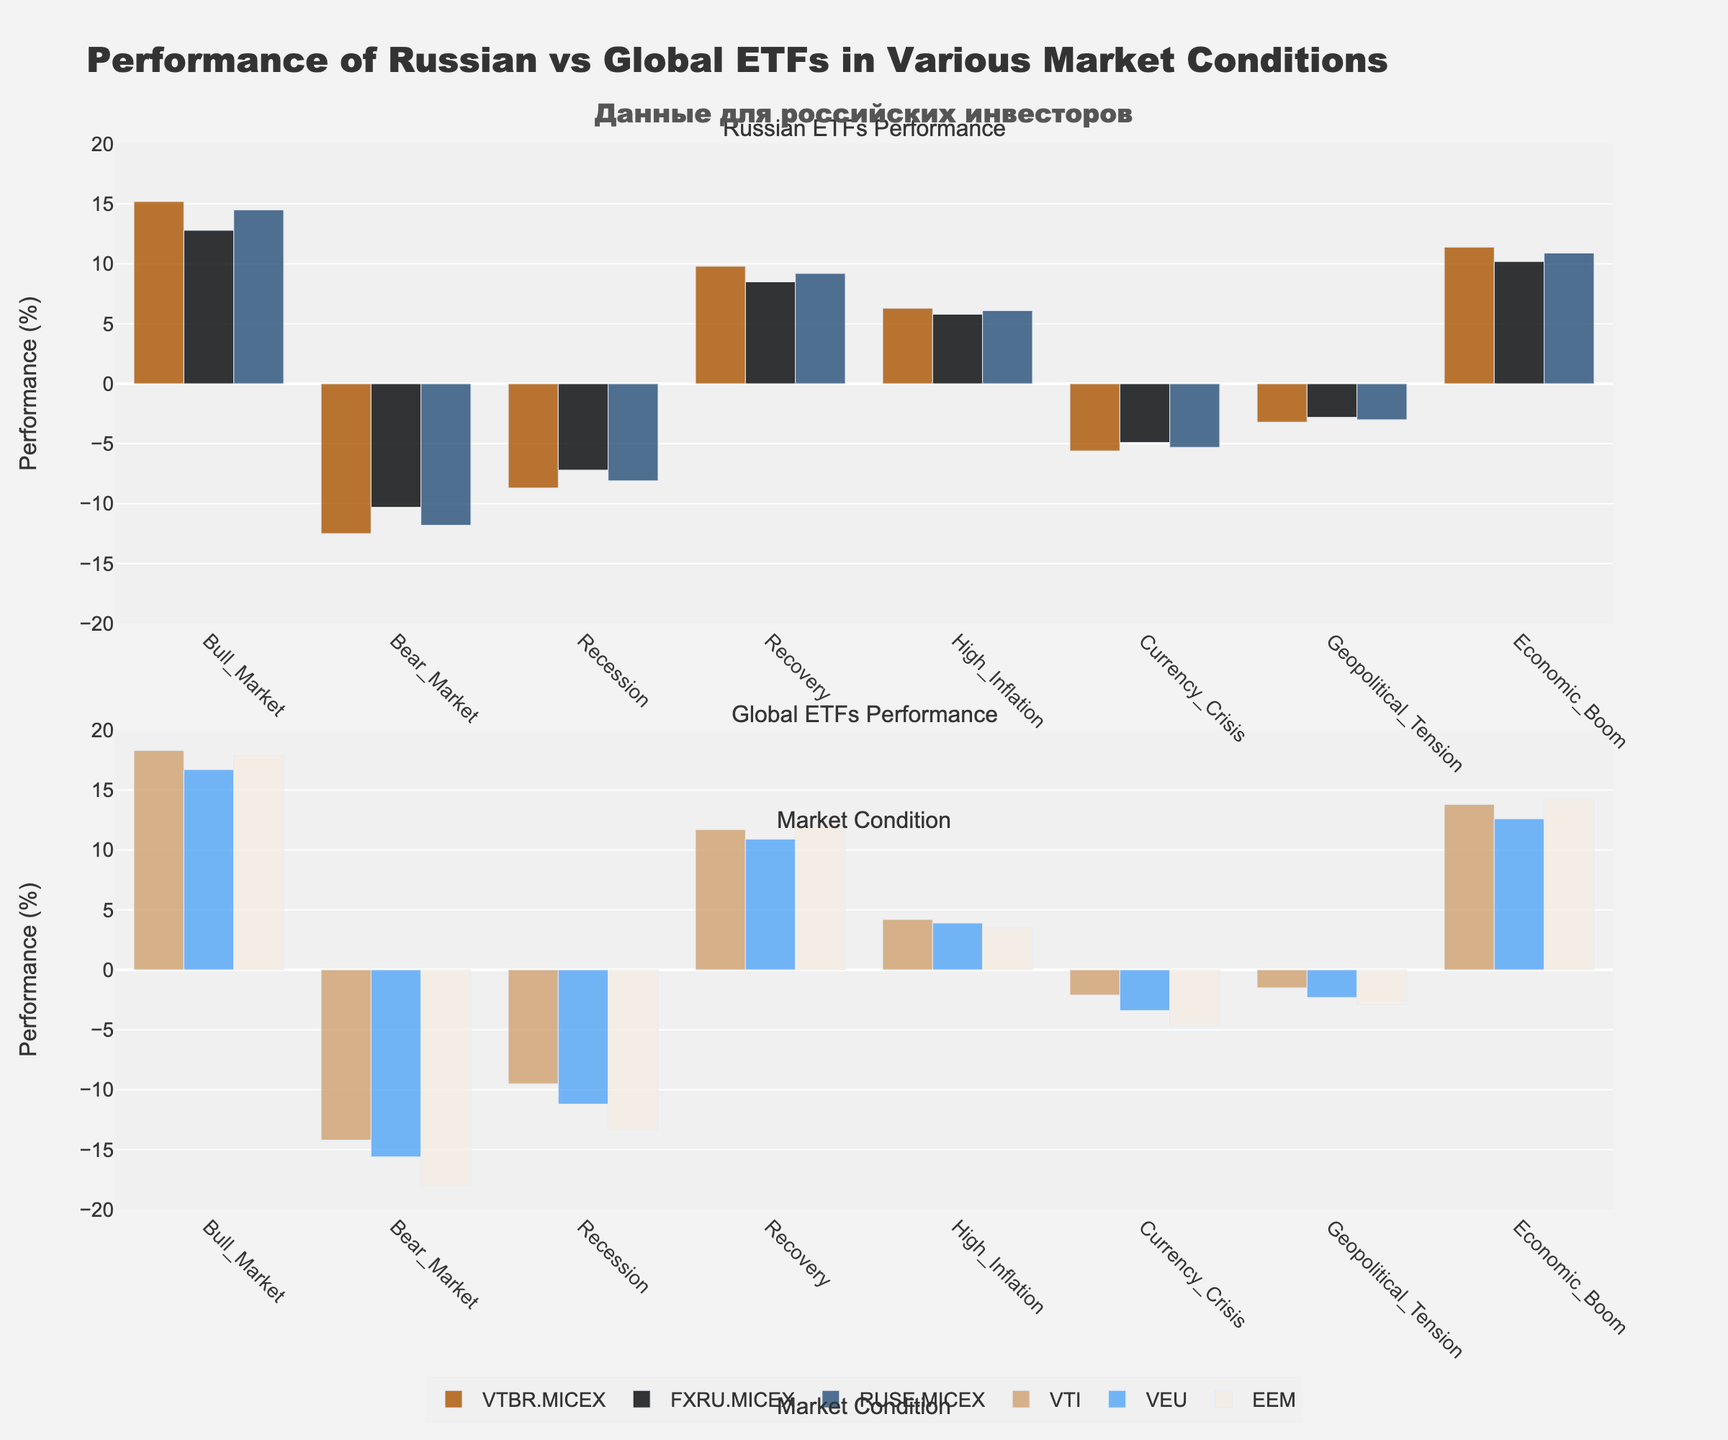Which market condition shows the best performance for Russian ETFs? The highest bars in the Russian ETFs subplot indicate the best performance. "Bull Market" has the highest values for all Russian ETFs.
Answer: Bull Market How do Russian ETFs perform in Bear Markets compared to Global ETFs? The Russian ETFs show performance values around -10.3 to -12.5, while Global ETFs show performance values around -14.2 to -18.1. Russian ETFs perform better as they have less negative values.
Answer: Better What is the difference in performance between VTBR.MICEX and EEM during a Geopolitical Tension market condition? VTBR.MICEX is at -3.2 while EEM is at -2.9. The difference in performance is -3.2 - (-2.9) = -0.3.
Answer: -0.3 What is the average performance of FXRU.MICEX across all reported market conditions? Summing FXRU.MICEX values: 12.8 + (-10.3) + (-7.2) + 8.5 + 5.8 + (-4.9) + (-2.8) + 10.2 = 12.1. There are 8 conditions, so the average is 12.1/8 = 1.5125.
Answer: 1.51 Which ETF shows the highest performance during an Economic Boom? In the subplot "Global ETFs Performance," the highest value is that of EEM with a value of 14.2.
Answer: EEM Are there any market conditions where VTI outperforms all Russian ETFs? In the Bull Market, Recession, Recovery, and Economic Boom conditions, VTI's values (18.3, -9.5, 11.7, 13.8 respectively) are greater than any Russian ETFs.
Answer: Yes During a High Inflation market condition, which Russian ETF performs best and which Global ETF performs worst? Among Russian ETFs, VTBR.MICEX performs best at 6.3 and among Global ETFs, EEM performs worst at 3.5.
Answer: VTBR.MICEX and EEM What's the sum of performances of Russian ETFs during a Currency Crisis versus Global ETFs? Sum Russian ETFs: -5.6 + (-4.9) + (-5.3) = -15.8; Sum Global ETFs: -2.1 + (-3.4) + (-4.7) = -10.2.
Answer: -15.8 and -10.2 Which ETF experiences the lowest performance during a Recession? In the Recession condition, EEM has the lowest performance value in the subplot "Global ETFs Performance" at -13.4.
Answer: EEM 